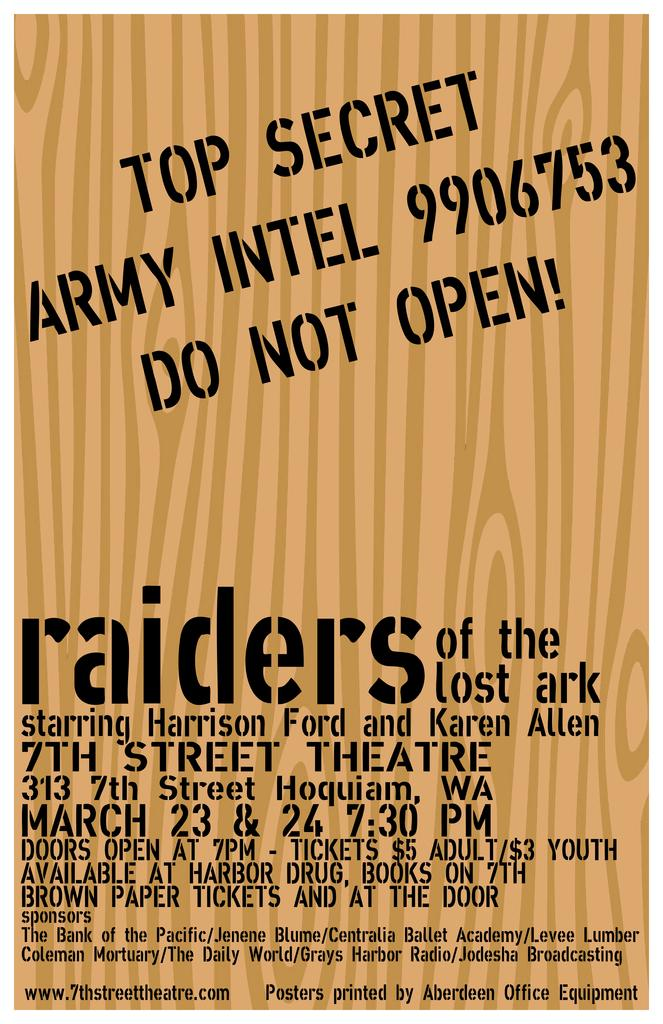Provide a one-sentence caption for the provided image. Here we have a poster that resembles a top secret Army intel file that advertises the movie Raiders of the Lost Ark. 